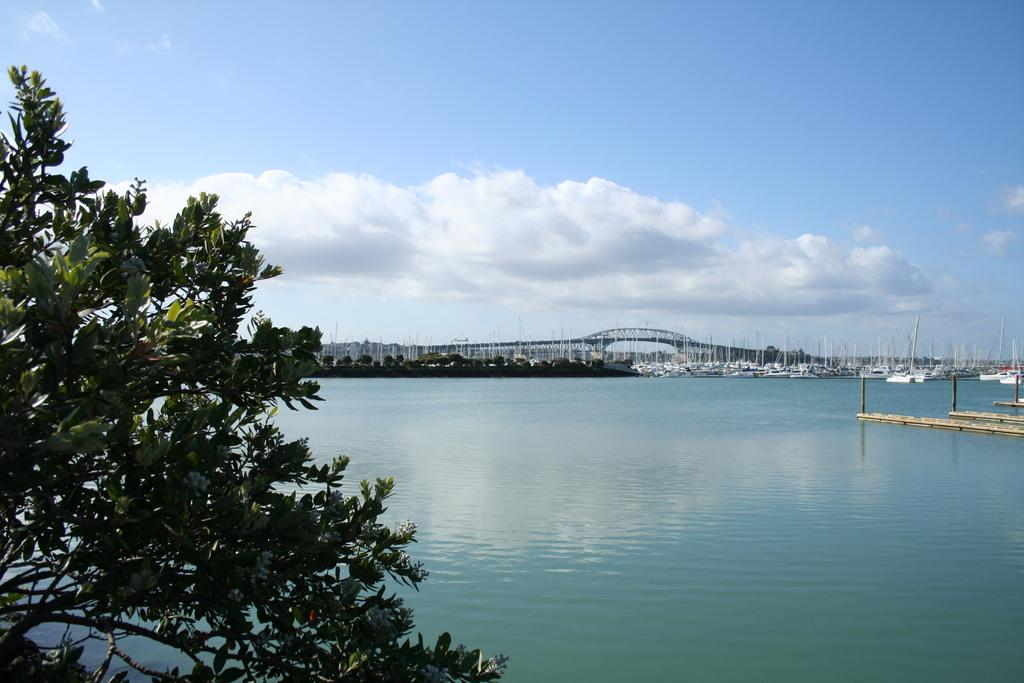What type of vehicles can be seen on the water in the image? There are boats on the water in the image. What structures are present near the water in the image? There are wooden piers and a bridge in the image. What type of vegetation is visible in the image? There are trees in the image. What can be seen in the background of the image? The sky is visible in the background of the image. What part of the boat is made of dimes in the image? There are no dimes present in the image; it features boats, wooden piers, a bridge, trees, and the sky. What type of selection is available for the boats in the image? There is no indication of a selection of boats in the image; it simply shows boats on the water. 